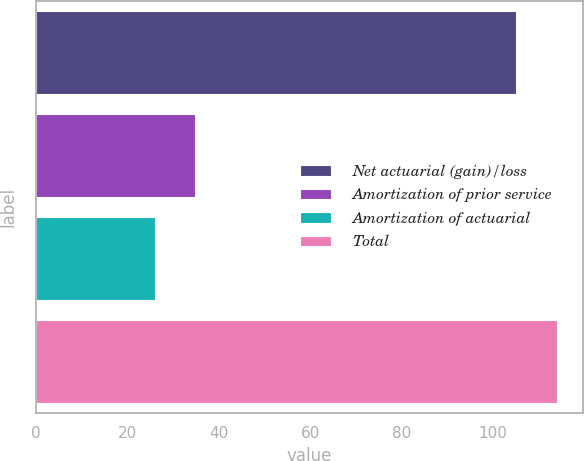Convert chart. <chart><loc_0><loc_0><loc_500><loc_500><bar_chart><fcel>Net actuarial (gain)/loss<fcel>Amortization of prior service<fcel>Amortization of actuarial<fcel>Total<nl><fcel>105<fcel>34.8<fcel>26<fcel>114<nl></chart> 